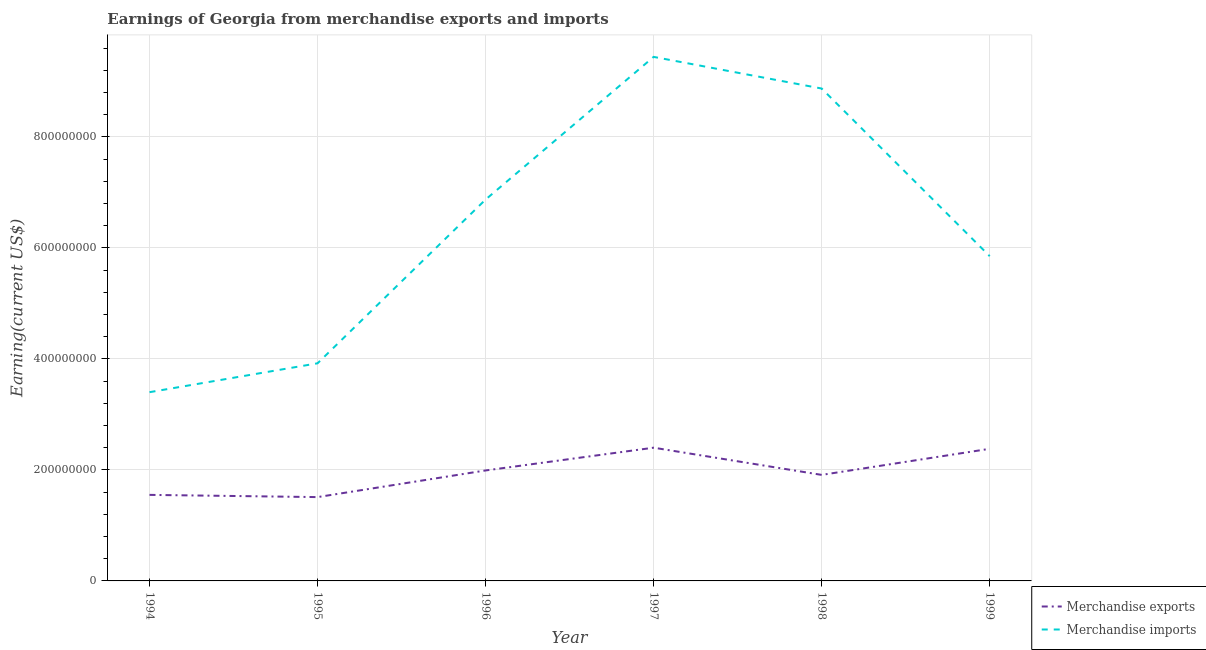Is the number of lines equal to the number of legend labels?
Ensure brevity in your answer.  Yes. What is the earnings from merchandise exports in 1994?
Offer a very short reply. 1.55e+08. Across all years, what is the maximum earnings from merchandise exports?
Offer a very short reply. 2.40e+08. Across all years, what is the minimum earnings from merchandise imports?
Give a very brief answer. 3.40e+08. In which year was the earnings from merchandise imports maximum?
Keep it short and to the point. 1997. In which year was the earnings from merchandise exports minimum?
Ensure brevity in your answer.  1995. What is the total earnings from merchandise imports in the graph?
Your response must be concise. 3.84e+09. What is the difference between the earnings from merchandise exports in 1996 and that in 1998?
Keep it short and to the point. 8.00e+06. What is the difference between the earnings from merchandise exports in 1999 and the earnings from merchandise imports in 1998?
Provide a succinct answer. -6.49e+08. What is the average earnings from merchandise exports per year?
Offer a very short reply. 1.96e+08. In the year 1998, what is the difference between the earnings from merchandise imports and earnings from merchandise exports?
Provide a succinct answer. 6.96e+08. In how many years, is the earnings from merchandise exports greater than 640000000 US$?
Provide a short and direct response. 0. What is the ratio of the earnings from merchandise imports in 1996 to that in 1997?
Ensure brevity in your answer.  0.73. What is the difference between the highest and the second highest earnings from merchandise exports?
Give a very brief answer. 2.00e+06. What is the difference between the highest and the lowest earnings from merchandise imports?
Give a very brief answer. 6.04e+08. In how many years, is the earnings from merchandise exports greater than the average earnings from merchandise exports taken over all years?
Your answer should be compact. 3. Is the sum of the earnings from merchandise imports in 1998 and 1999 greater than the maximum earnings from merchandise exports across all years?
Provide a succinct answer. Yes. Does the earnings from merchandise imports monotonically increase over the years?
Your response must be concise. No. Is the earnings from merchandise exports strictly greater than the earnings from merchandise imports over the years?
Your response must be concise. No. Does the graph contain any zero values?
Provide a succinct answer. No. How many legend labels are there?
Make the answer very short. 2. How are the legend labels stacked?
Your answer should be compact. Vertical. What is the title of the graph?
Provide a succinct answer. Earnings of Georgia from merchandise exports and imports. Does "Lower secondary education" appear as one of the legend labels in the graph?
Provide a short and direct response. No. What is the label or title of the X-axis?
Your answer should be very brief. Year. What is the label or title of the Y-axis?
Offer a terse response. Earning(current US$). What is the Earning(current US$) of Merchandise exports in 1994?
Your answer should be compact. 1.55e+08. What is the Earning(current US$) of Merchandise imports in 1994?
Provide a short and direct response. 3.40e+08. What is the Earning(current US$) in Merchandise exports in 1995?
Keep it short and to the point. 1.51e+08. What is the Earning(current US$) of Merchandise imports in 1995?
Keep it short and to the point. 3.92e+08. What is the Earning(current US$) of Merchandise exports in 1996?
Give a very brief answer. 1.99e+08. What is the Earning(current US$) in Merchandise imports in 1996?
Give a very brief answer. 6.87e+08. What is the Earning(current US$) of Merchandise exports in 1997?
Provide a short and direct response. 2.40e+08. What is the Earning(current US$) in Merchandise imports in 1997?
Give a very brief answer. 9.44e+08. What is the Earning(current US$) in Merchandise exports in 1998?
Your response must be concise. 1.91e+08. What is the Earning(current US$) in Merchandise imports in 1998?
Your answer should be very brief. 8.87e+08. What is the Earning(current US$) of Merchandise exports in 1999?
Provide a succinct answer. 2.38e+08. What is the Earning(current US$) of Merchandise imports in 1999?
Your answer should be very brief. 5.85e+08. Across all years, what is the maximum Earning(current US$) in Merchandise exports?
Make the answer very short. 2.40e+08. Across all years, what is the maximum Earning(current US$) of Merchandise imports?
Keep it short and to the point. 9.44e+08. Across all years, what is the minimum Earning(current US$) of Merchandise exports?
Keep it short and to the point. 1.51e+08. Across all years, what is the minimum Earning(current US$) in Merchandise imports?
Offer a very short reply. 3.40e+08. What is the total Earning(current US$) in Merchandise exports in the graph?
Ensure brevity in your answer.  1.17e+09. What is the total Earning(current US$) of Merchandise imports in the graph?
Your response must be concise. 3.84e+09. What is the difference between the Earning(current US$) in Merchandise exports in 1994 and that in 1995?
Your answer should be very brief. 4.00e+06. What is the difference between the Earning(current US$) of Merchandise imports in 1994 and that in 1995?
Give a very brief answer. -5.20e+07. What is the difference between the Earning(current US$) of Merchandise exports in 1994 and that in 1996?
Your response must be concise. -4.40e+07. What is the difference between the Earning(current US$) in Merchandise imports in 1994 and that in 1996?
Keep it short and to the point. -3.47e+08. What is the difference between the Earning(current US$) of Merchandise exports in 1994 and that in 1997?
Your answer should be very brief. -8.50e+07. What is the difference between the Earning(current US$) of Merchandise imports in 1994 and that in 1997?
Make the answer very short. -6.04e+08. What is the difference between the Earning(current US$) of Merchandise exports in 1994 and that in 1998?
Your answer should be compact. -3.60e+07. What is the difference between the Earning(current US$) in Merchandise imports in 1994 and that in 1998?
Offer a terse response. -5.47e+08. What is the difference between the Earning(current US$) in Merchandise exports in 1994 and that in 1999?
Your answer should be very brief. -8.30e+07. What is the difference between the Earning(current US$) in Merchandise imports in 1994 and that in 1999?
Your answer should be compact. -2.45e+08. What is the difference between the Earning(current US$) of Merchandise exports in 1995 and that in 1996?
Give a very brief answer. -4.80e+07. What is the difference between the Earning(current US$) of Merchandise imports in 1995 and that in 1996?
Your response must be concise. -2.95e+08. What is the difference between the Earning(current US$) in Merchandise exports in 1995 and that in 1997?
Provide a succinct answer. -8.90e+07. What is the difference between the Earning(current US$) of Merchandise imports in 1995 and that in 1997?
Keep it short and to the point. -5.52e+08. What is the difference between the Earning(current US$) of Merchandise exports in 1995 and that in 1998?
Ensure brevity in your answer.  -4.00e+07. What is the difference between the Earning(current US$) of Merchandise imports in 1995 and that in 1998?
Give a very brief answer. -4.95e+08. What is the difference between the Earning(current US$) of Merchandise exports in 1995 and that in 1999?
Your answer should be very brief. -8.70e+07. What is the difference between the Earning(current US$) of Merchandise imports in 1995 and that in 1999?
Offer a terse response. -1.93e+08. What is the difference between the Earning(current US$) in Merchandise exports in 1996 and that in 1997?
Offer a terse response. -4.10e+07. What is the difference between the Earning(current US$) of Merchandise imports in 1996 and that in 1997?
Offer a very short reply. -2.57e+08. What is the difference between the Earning(current US$) in Merchandise exports in 1996 and that in 1998?
Offer a terse response. 8.00e+06. What is the difference between the Earning(current US$) of Merchandise imports in 1996 and that in 1998?
Your answer should be very brief. -2.00e+08. What is the difference between the Earning(current US$) in Merchandise exports in 1996 and that in 1999?
Ensure brevity in your answer.  -3.90e+07. What is the difference between the Earning(current US$) of Merchandise imports in 1996 and that in 1999?
Provide a short and direct response. 1.02e+08. What is the difference between the Earning(current US$) in Merchandise exports in 1997 and that in 1998?
Ensure brevity in your answer.  4.90e+07. What is the difference between the Earning(current US$) in Merchandise imports in 1997 and that in 1998?
Give a very brief answer. 5.70e+07. What is the difference between the Earning(current US$) in Merchandise imports in 1997 and that in 1999?
Your response must be concise. 3.59e+08. What is the difference between the Earning(current US$) in Merchandise exports in 1998 and that in 1999?
Keep it short and to the point. -4.70e+07. What is the difference between the Earning(current US$) in Merchandise imports in 1998 and that in 1999?
Your answer should be very brief. 3.02e+08. What is the difference between the Earning(current US$) of Merchandise exports in 1994 and the Earning(current US$) of Merchandise imports in 1995?
Give a very brief answer. -2.37e+08. What is the difference between the Earning(current US$) in Merchandise exports in 1994 and the Earning(current US$) in Merchandise imports in 1996?
Offer a very short reply. -5.32e+08. What is the difference between the Earning(current US$) of Merchandise exports in 1994 and the Earning(current US$) of Merchandise imports in 1997?
Your answer should be compact. -7.89e+08. What is the difference between the Earning(current US$) in Merchandise exports in 1994 and the Earning(current US$) in Merchandise imports in 1998?
Keep it short and to the point. -7.32e+08. What is the difference between the Earning(current US$) of Merchandise exports in 1994 and the Earning(current US$) of Merchandise imports in 1999?
Make the answer very short. -4.30e+08. What is the difference between the Earning(current US$) in Merchandise exports in 1995 and the Earning(current US$) in Merchandise imports in 1996?
Offer a terse response. -5.36e+08. What is the difference between the Earning(current US$) of Merchandise exports in 1995 and the Earning(current US$) of Merchandise imports in 1997?
Make the answer very short. -7.93e+08. What is the difference between the Earning(current US$) of Merchandise exports in 1995 and the Earning(current US$) of Merchandise imports in 1998?
Keep it short and to the point. -7.36e+08. What is the difference between the Earning(current US$) in Merchandise exports in 1995 and the Earning(current US$) in Merchandise imports in 1999?
Provide a succinct answer. -4.34e+08. What is the difference between the Earning(current US$) in Merchandise exports in 1996 and the Earning(current US$) in Merchandise imports in 1997?
Keep it short and to the point. -7.45e+08. What is the difference between the Earning(current US$) in Merchandise exports in 1996 and the Earning(current US$) in Merchandise imports in 1998?
Your answer should be compact. -6.88e+08. What is the difference between the Earning(current US$) of Merchandise exports in 1996 and the Earning(current US$) of Merchandise imports in 1999?
Offer a terse response. -3.86e+08. What is the difference between the Earning(current US$) in Merchandise exports in 1997 and the Earning(current US$) in Merchandise imports in 1998?
Ensure brevity in your answer.  -6.47e+08. What is the difference between the Earning(current US$) of Merchandise exports in 1997 and the Earning(current US$) of Merchandise imports in 1999?
Give a very brief answer. -3.45e+08. What is the difference between the Earning(current US$) of Merchandise exports in 1998 and the Earning(current US$) of Merchandise imports in 1999?
Provide a short and direct response. -3.94e+08. What is the average Earning(current US$) in Merchandise exports per year?
Offer a terse response. 1.96e+08. What is the average Earning(current US$) of Merchandise imports per year?
Offer a very short reply. 6.39e+08. In the year 1994, what is the difference between the Earning(current US$) of Merchandise exports and Earning(current US$) of Merchandise imports?
Your response must be concise. -1.85e+08. In the year 1995, what is the difference between the Earning(current US$) of Merchandise exports and Earning(current US$) of Merchandise imports?
Offer a very short reply. -2.41e+08. In the year 1996, what is the difference between the Earning(current US$) in Merchandise exports and Earning(current US$) in Merchandise imports?
Your answer should be compact. -4.88e+08. In the year 1997, what is the difference between the Earning(current US$) in Merchandise exports and Earning(current US$) in Merchandise imports?
Make the answer very short. -7.04e+08. In the year 1998, what is the difference between the Earning(current US$) of Merchandise exports and Earning(current US$) of Merchandise imports?
Your answer should be very brief. -6.96e+08. In the year 1999, what is the difference between the Earning(current US$) of Merchandise exports and Earning(current US$) of Merchandise imports?
Offer a terse response. -3.47e+08. What is the ratio of the Earning(current US$) of Merchandise exports in 1994 to that in 1995?
Your response must be concise. 1.03. What is the ratio of the Earning(current US$) of Merchandise imports in 1994 to that in 1995?
Your answer should be compact. 0.87. What is the ratio of the Earning(current US$) in Merchandise exports in 1994 to that in 1996?
Provide a succinct answer. 0.78. What is the ratio of the Earning(current US$) in Merchandise imports in 1994 to that in 1996?
Offer a terse response. 0.49. What is the ratio of the Earning(current US$) in Merchandise exports in 1994 to that in 1997?
Ensure brevity in your answer.  0.65. What is the ratio of the Earning(current US$) in Merchandise imports in 1994 to that in 1997?
Offer a terse response. 0.36. What is the ratio of the Earning(current US$) of Merchandise exports in 1994 to that in 1998?
Your answer should be very brief. 0.81. What is the ratio of the Earning(current US$) of Merchandise imports in 1994 to that in 1998?
Offer a very short reply. 0.38. What is the ratio of the Earning(current US$) in Merchandise exports in 1994 to that in 1999?
Make the answer very short. 0.65. What is the ratio of the Earning(current US$) in Merchandise imports in 1994 to that in 1999?
Your response must be concise. 0.58. What is the ratio of the Earning(current US$) in Merchandise exports in 1995 to that in 1996?
Give a very brief answer. 0.76. What is the ratio of the Earning(current US$) in Merchandise imports in 1995 to that in 1996?
Give a very brief answer. 0.57. What is the ratio of the Earning(current US$) in Merchandise exports in 1995 to that in 1997?
Offer a terse response. 0.63. What is the ratio of the Earning(current US$) of Merchandise imports in 1995 to that in 1997?
Keep it short and to the point. 0.42. What is the ratio of the Earning(current US$) of Merchandise exports in 1995 to that in 1998?
Keep it short and to the point. 0.79. What is the ratio of the Earning(current US$) of Merchandise imports in 1995 to that in 1998?
Your response must be concise. 0.44. What is the ratio of the Earning(current US$) of Merchandise exports in 1995 to that in 1999?
Provide a succinct answer. 0.63. What is the ratio of the Earning(current US$) of Merchandise imports in 1995 to that in 1999?
Provide a short and direct response. 0.67. What is the ratio of the Earning(current US$) in Merchandise exports in 1996 to that in 1997?
Provide a succinct answer. 0.83. What is the ratio of the Earning(current US$) of Merchandise imports in 1996 to that in 1997?
Your answer should be very brief. 0.73. What is the ratio of the Earning(current US$) in Merchandise exports in 1996 to that in 1998?
Make the answer very short. 1.04. What is the ratio of the Earning(current US$) of Merchandise imports in 1996 to that in 1998?
Offer a very short reply. 0.77. What is the ratio of the Earning(current US$) of Merchandise exports in 1996 to that in 1999?
Provide a succinct answer. 0.84. What is the ratio of the Earning(current US$) in Merchandise imports in 1996 to that in 1999?
Provide a short and direct response. 1.17. What is the ratio of the Earning(current US$) in Merchandise exports in 1997 to that in 1998?
Your response must be concise. 1.26. What is the ratio of the Earning(current US$) of Merchandise imports in 1997 to that in 1998?
Your answer should be compact. 1.06. What is the ratio of the Earning(current US$) of Merchandise exports in 1997 to that in 1999?
Your response must be concise. 1.01. What is the ratio of the Earning(current US$) of Merchandise imports in 1997 to that in 1999?
Your answer should be very brief. 1.61. What is the ratio of the Earning(current US$) in Merchandise exports in 1998 to that in 1999?
Make the answer very short. 0.8. What is the ratio of the Earning(current US$) of Merchandise imports in 1998 to that in 1999?
Your answer should be compact. 1.52. What is the difference between the highest and the second highest Earning(current US$) in Merchandise exports?
Provide a short and direct response. 2.00e+06. What is the difference between the highest and the second highest Earning(current US$) of Merchandise imports?
Your response must be concise. 5.70e+07. What is the difference between the highest and the lowest Earning(current US$) in Merchandise exports?
Keep it short and to the point. 8.90e+07. What is the difference between the highest and the lowest Earning(current US$) in Merchandise imports?
Offer a very short reply. 6.04e+08. 